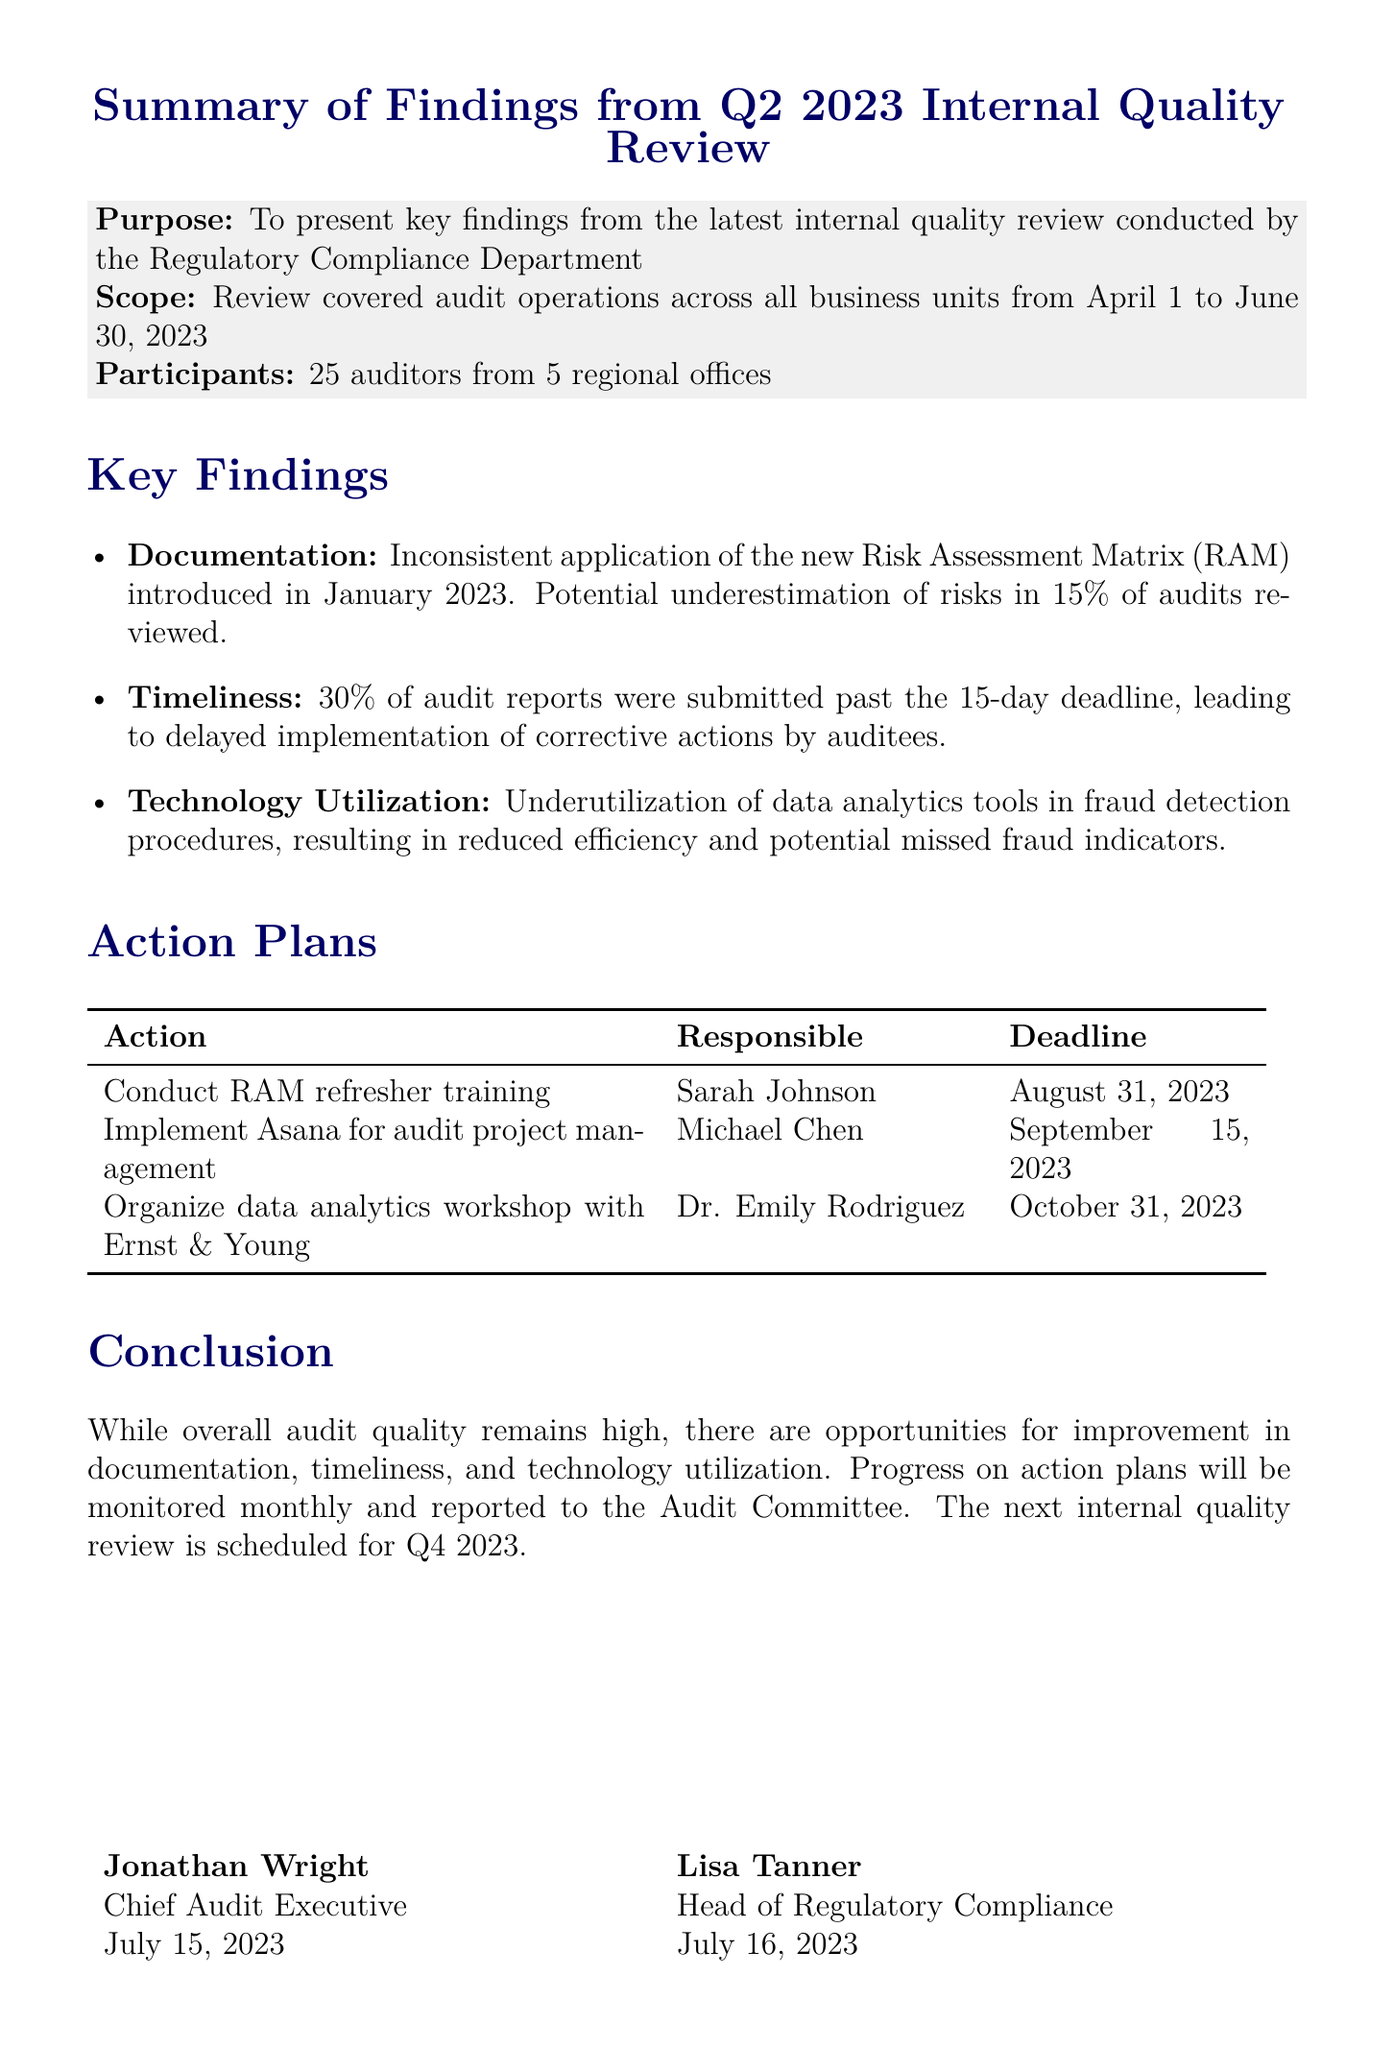What is the purpose of the memo? The purpose of the memo is stated explicitly to present key findings from the latest internal quality review conducted by the Regulatory Compliance Department.
Answer: To present key findings from the latest internal quality review What percentage of audit reports were submitted past the deadline? The memo highlights that 30% of audit reports were submitted past the 15-day deadline.
Answer: 30% Who is responsible for conducting the RAM refresher training? The document specifies that Sarah Johnson, Senior Training Specialist, is responsible for this action.
Answer: Sarah Johnson What is the deadline for implementing Asana for audit project management? The deadline for implementing Asana is clearly mentioned as September 15, 2023.
Answer: September 15, 2023 Which area has the highest potential impact according to the findings? The findings indicate that the inconsistent application of the new Risk Assessment Matrix may lead to a potential underestimation of risks in 15% of audits reviewed, suggesting significant impact.
Answer: 15% What is the action planned for technology utilization improvement? The action planned to improve technology utilization is to partner with Ernst & Young to provide advanced data analytics training.
Answer: Partner with Ernst & Young to provide advanced data analytics training When is the next internal quality review scheduled? The memo concludes with the next internal quality review being scheduled for Q4 2023, indicating future evaluation.
Answer: Q4 2023 What are the primary areas for improvement identified in the memo? The primary areas for improvement include documentation, timeliness, and technology utilization, as directly stated in the document.
Answer: Documentation, timeliness, and technology utilization 